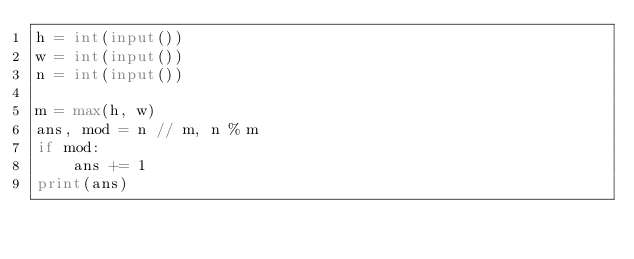<code> <loc_0><loc_0><loc_500><loc_500><_Python_>h = int(input())
w = int(input())
n = int(input())

m = max(h, w)
ans, mod = n // m, n % m
if mod:
    ans += 1
print(ans)

</code> 